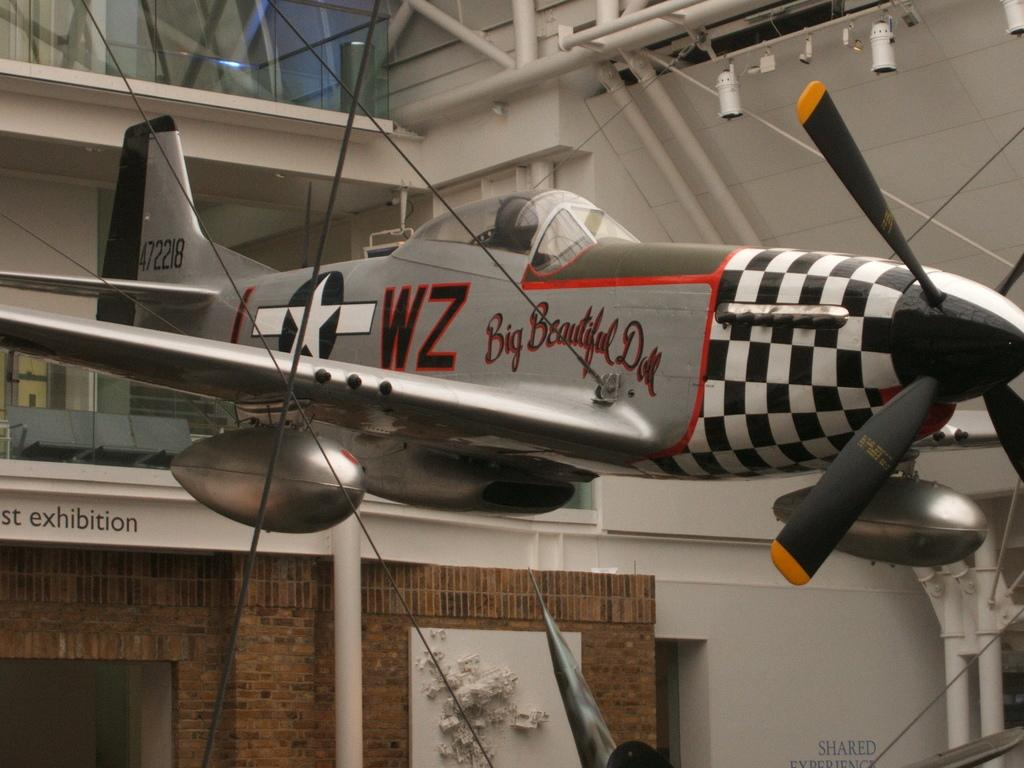What is the main subject of the image? The main subject of the image is an airplane. How is the airplane secured in the image? The airplane is tied with cables in the image. Where is the airplane located in the image? The airplane is inside a building in the image. What can be seen in the background of the image? There are police lights and chairs in the background of the image. What type of engine is powering the airplane in the image? The image does not show the airplane's engine, so it cannot be determined from the image. How many birthday candles are on the cake in the image? There is no cake or birthday candles present in the image. 